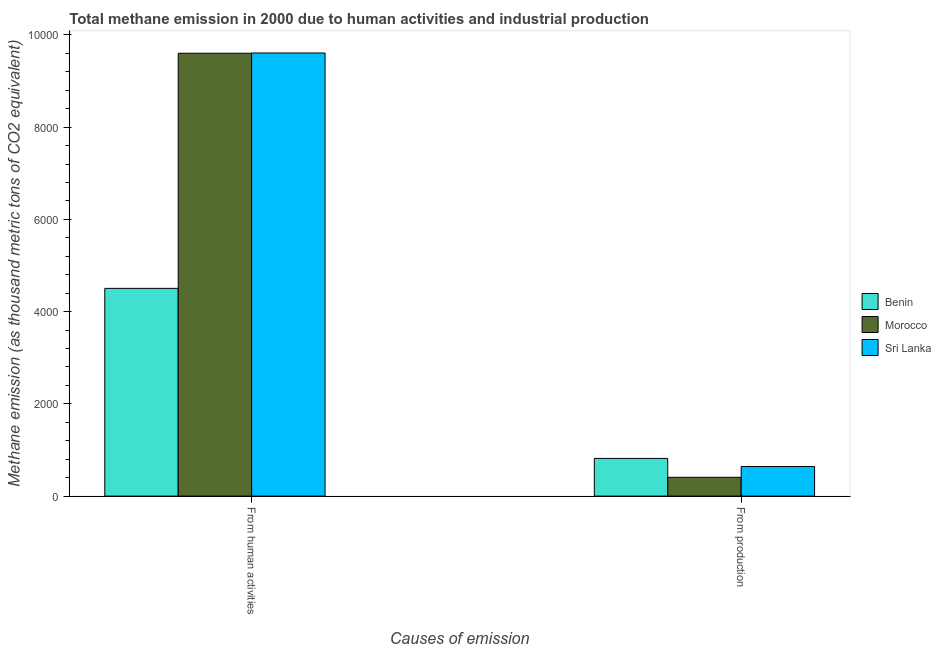How many groups of bars are there?
Provide a short and direct response. 2. Are the number of bars per tick equal to the number of legend labels?
Offer a terse response. Yes. Are the number of bars on each tick of the X-axis equal?
Offer a very short reply. Yes. How many bars are there on the 2nd tick from the left?
Give a very brief answer. 3. How many bars are there on the 2nd tick from the right?
Make the answer very short. 3. What is the label of the 2nd group of bars from the left?
Provide a short and direct response. From production. What is the amount of emissions from human activities in Benin?
Provide a succinct answer. 4503.8. Across all countries, what is the maximum amount of emissions from human activities?
Your response must be concise. 9607.2. Across all countries, what is the minimum amount of emissions generated from industries?
Give a very brief answer. 407.6. In which country was the amount of emissions generated from industries maximum?
Your answer should be very brief. Benin. In which country was the amount of emissions from human activities minimum?
Your answer should be very brief. Benin. What is the total amount of emissions from human activities in the graph?
Make the answer very short. 2.37e+04. What is the difference between the amount of emissions generated from industries in Benin and that in Sri Lanka?
Keep it short and to the point. 175. What is the difference between the amount of emissions generated from industries in Sri Lanka and the amount of emissions from human activities in Benin?
Keep it short and to the point. -3861.6. What is the average amount of emissions from human activities per country?
Your answer should be compact. 7904.17. What is the difference between the amount of emissions from human activities and amount of emissions generated from industries in Sri Lanka?
Provide a succinct answer. 8965. What is the ratio of the amount of emissions generated from industries in Benin to that in Morocco?
Give a very brief answer. 2. Is the amount of emissions from human activities in Sri Lanka less than that in Morocco?
Provide a short and direct response. No. What does the 3rd bar from the left in From production represents?
Provide a short and direct response. Sri Lanka. What does the 3rd bar from the right in From production represents?
Offer a terse response. Benin. How many bars are there?
Make the answer very short. 6. How many countries are there in the graph?
Keep it short and to the point. 3. What is the difference between two consecutive major ticks on the Y-axis?
Your answer should be very brief. 2000. Are the values on the major ticks of Y-axis written in scientific E-notation?
Keep it short and to the point. No. Where does the legend appear in the graph?
Your response must be concise. Center right. How many legend labels are there?
Offer a very short reply. 3. What is the title of the graph?
Provide a short and direct response. Total methane emission in 2000 due to human activities and industrial production. What is the label or title of the X-axis?
Offer a terse response. Causes of emission. What is the label or title of the Y-axis?
Offer a terse response. Methane emission (as thousand metric tons of CO2 equivalent). What is the Methane emission (as thousand metric tons of CO2 equivalent) of Benin in From human activities?
Offer a very short reply. 4503.8. What is the Methane emission (as thousand metric tons of CO2 equivalent) in Morocco in From human activities?
Offer a very short reply. 9601.5. What is the Methane emission (as thousand metric tons of CO2 equivalent) of Sri Lanka in From human activities?
Make the answer very short. 9607.2. What is the Methane emission (as thousand metric tons of CO2 equivalent) of Benin in From production?
Offer a terse response. 817.2. What is the Methane emission (as thousand metric tons of CO2 equivalent) of Morocco in From production?
Make the answer very short. 407.6. What is the Methane emission (as thousand metric tons of CO2 equivalent) in Sri Lanka in From production?
Offer a very short reply. 642.2. Across all Causes of emission, what is the maximum Methane emission (as thousand metric tons of CO2 equivalent) of Benin?
Ensure brevity in your answer.  4503.8. Across all Causes of emission, what is the maximum Methane emission (as thousand metric tons of CO2 equivalent) in Morocco?
Offer a terse response. 9601.5. Across all Causes of emission, what is the maximum Methane emission (as thousand metric tons of CO2 equivalent) in Sri Lanka?
Ensure brevity in your answer.  9607.2. Across all Causes of emission, what is the minimum Methane emission (as thousand metric tons of CO2 equivalent) of Benin?
Offer a terse response. 817.2. Across all Causes of emission, what is the minimum Methane emission (as thousand metric tons of CO2 equivalent) in Morocco?
Ensure brevity in your answer.  407.6. Across all Causes of emission, what is the minimum Methane emission (as thousand metric tons of CO2 equivalent) of Sri Lanka?
Ensure brevity in your answer.  642.2. What is the total Methane emission (as thousand metric tons of CO2 equivalent) in Benin in the graph?
Your response must be concise. 5321. What is the total Methane emission (as thousand metric tons of CO2 equivalent) of Morocco in the graph?
Offer a terse response. 1.00e+04. What is the total Methane emission (as thousand metric tons of CO2 equivalent) in Sri Lanka in the graph?
Your response must be concise. 1.02e+04. What is the difference between the Methane emission (as thousand metric tons of CO2 equivalent) of Benin in From human activities and that in From production?
Keep it short and to the point. 3686.6. What is the difference between the Methane emission (as thousand metric tons of CO2 equivalent) in Morocco in From human activities and that in From production?
Offer a terse response. 9193.9. What is the difference between the Methane emission (as thousand metric tons of CO2 equivalent) in Sri Lanka in From human activities and that in From production?
Offer a terse response. 8965. What is the difference between the Methane emission (as thousand metric tons of CO2 equivalent) of Benin in From human activities and the Methane emission (as thousand metric tons of CO2 equivalent) of Morocco in From production?
Keep it short and to the point. 4096.2. What is the difference between the Methane emission (as thousand metric tons of CO2 equivalent) in Benin in From human activities and the Methane emission (as thousand metric tons of CO2 equivalent) in Sri Lanka in From production?
Your answer should be compact. 3861.6. What is the difference between the Methane emission (as thousand metric tons of CO2 equivalent) of Morocco in From human activities and the Methane emission (as thousand metric tons of CO2 equivalent) of Sri Lanka in From production?
Your answer should be compact. 8959.3. What is the average Methane emission (as thousand metric tons of CO2 equivalent) in Benin per Causes of emission?
Your response must be concise. 2660.5. What is the average Methane emission (as thousand metric tons of CO2 equivalent) of Morocco per Causes of emission?
Ensure brevity in your answer.  5004.55. What is the average Methane emission (as thousand metric tons of CO2 equivalent) in Sri Lanka per Causes of emission?
Give a very brief answer. 5124.7. What is the difference between the Methane emission (as thousand metric tons of CO2 equivalent) of Benin and Methane emission (as thousand metric tons of CO2 equivalent) of Morocco in From human activities?
Offer a terse response. -5097.7. What is the difference between the Methane emission (as thousand metric tons of CO2 equivalent) of Benin and Methane emission (as thousand metric tons of CO2 equivalent) of Sri Lanka in From human activities?
Your answer should be compact. -5103.4. What is the difference between the Methane emission (as thousand metric tons of CO2 equivalent) of Benin and Methane emission (as thousand metric tons of CO2 equivalent) of Morocco in From production?
Offer a terse response. 409.6. What is the difference between the Methane emission (as thousand metric tons of CO2 equivalent) in Benin and Methane emission (as thousand metric tons of CO2 equivalent) in Sri Lanka in From production?
Your response must be concise. 175. What is the difference between the Methane emission (as thousand metric tons of CO2 equivalent) in Morocco and Methane emission (as thousand metric tons of CO2 equivalent) in Sri Lanka in From production?
Make the answer very short. -234.6. What is the ratio of the Methane emission (as thousand metric tons of CO2 equivalent) in Benin in From human activities to that in From production?
Keep it short and to the point. 5.51. What is the ratio of the Methane emission (as thousand metric tons of CO2 equivalent) of Morocco in From human activities to that in From production?
Your answer should be very brief. 23.56. What is the ratio of the Methane emission (as thousand metric tons of CO2 equivalent) of Sri Lanka in From human activities to that in From production?
Keep it short and to the point. 14.96. What is the difference between the highest and the second highest Methane emission (as thousand metric tons of CO2 equivalent) in Benin?
Give a very brief answer. 3686.6. What is the difference between the highest and the second highest Methane emission (as thousand metric tons of CO2 equivalent) in Morocco?
Provide a short and direct response. 9193.9. What is the difference between the highest and the second highest Methane emission (as thousand metric tons of CO2 equivalent) in Sri Lanka?
Your answer should be very brief. 8965. What is the difference between the highest and the lowest Methane emission (as thousand metric tons of CO2 equivalent) of Benin?
Give a very brief answer. 3686.6. What is the difference between the highest and the lowest Methane emission (as thousand metric tons of CO2 equivalent) in Morocco?
Your answer should be compact. 9193.9. What is the difference between the highest and the lowest Methane emission (as thousand metric tons of CO2 equivalent) of Sri Lanka?
Your response must be concise. 8965. 